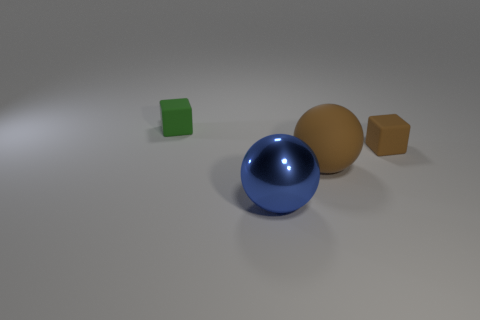Add 3 large blue spheres. How many objects exist? 7 Add 2 small rubber cubes. How many small rubber cubes exist? 4 Subtract 0 green balls. How many objects are left? 4 Subtract all large cubes. Subtract all shiny spheres. How many objects are left? 3 Add 4 large brown balls. How many large brown balls are left? 5 